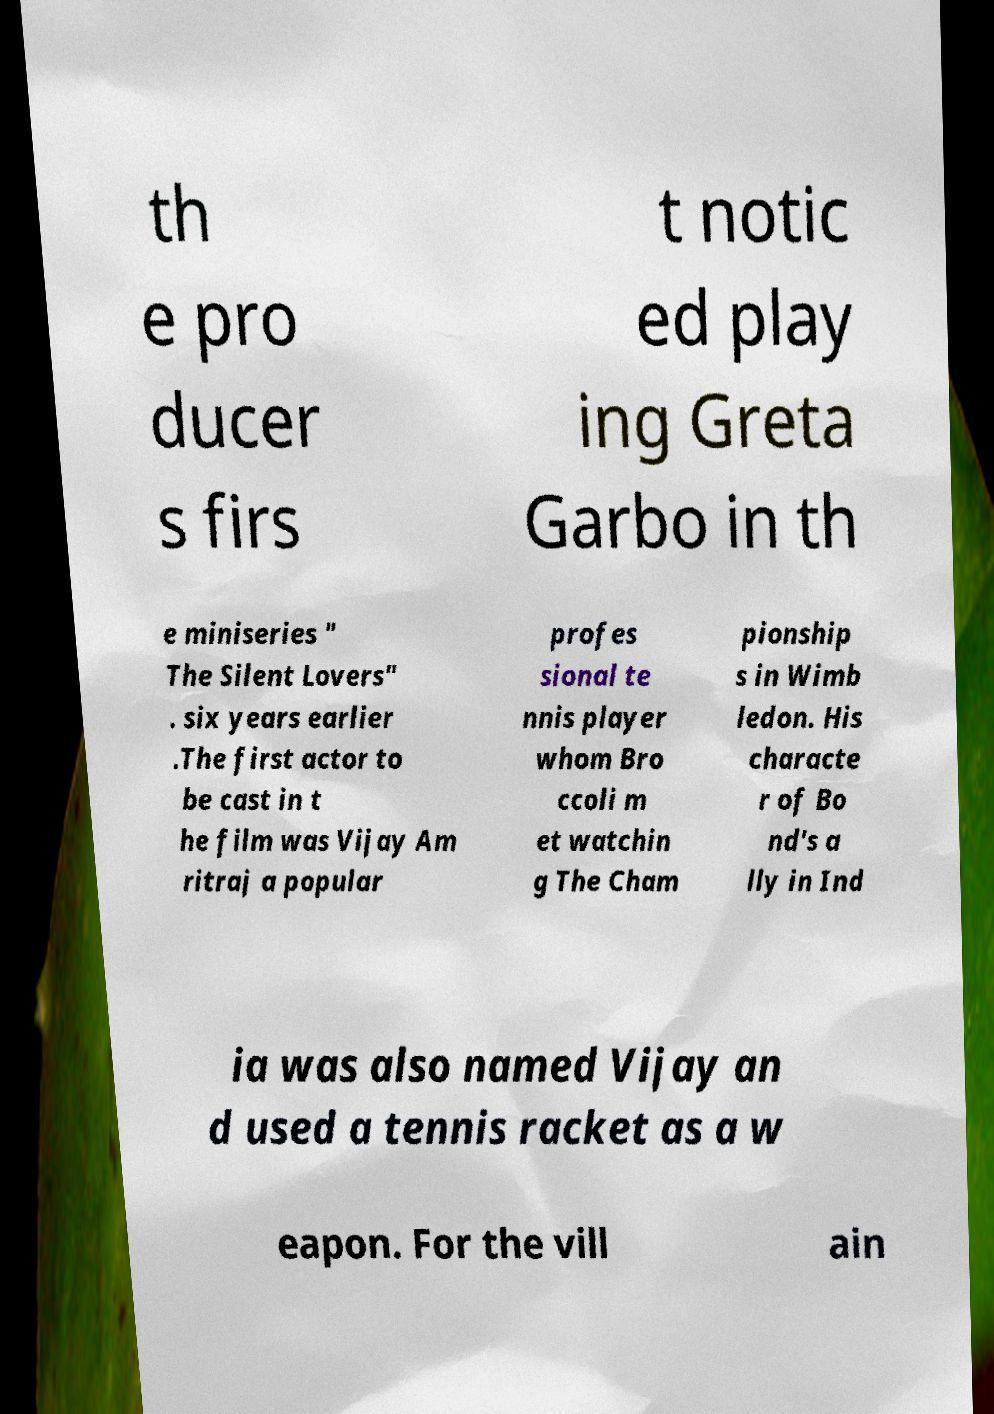Can you accurately transcribe the text from the provided image for me? th e pro ducer s firs t notic ed play ing Greta Garbo in th e miniseries " The Silent Lovers" . six years earlier .The first actor to be cast in t he film was Vijay Am ritraj a popular profes sional te nnis player whom Bro ccoli m et watchin g The Cham pionship s in Wimb ledon. His characte r of Bo nd's a lly in Ind ia was also named Vijay an d used a tennis racket as a w eapon. For the vill ain 